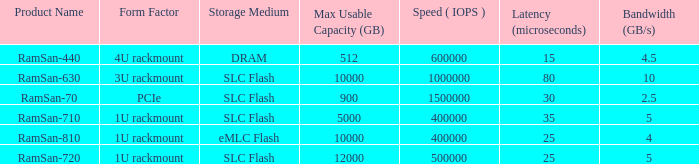What is the read/write operations per second for the emlc flash? 400000.0. 